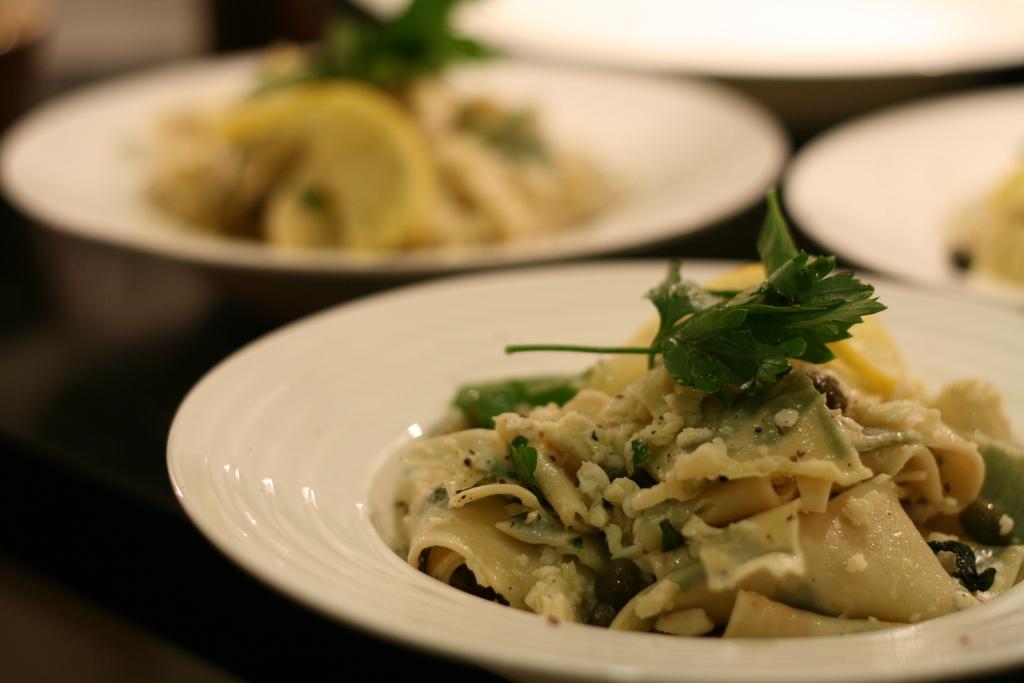In one or two sentences, can you explain what this image depicts? In this image we can see the plates on the table. Here we can see the dish on the plate. 